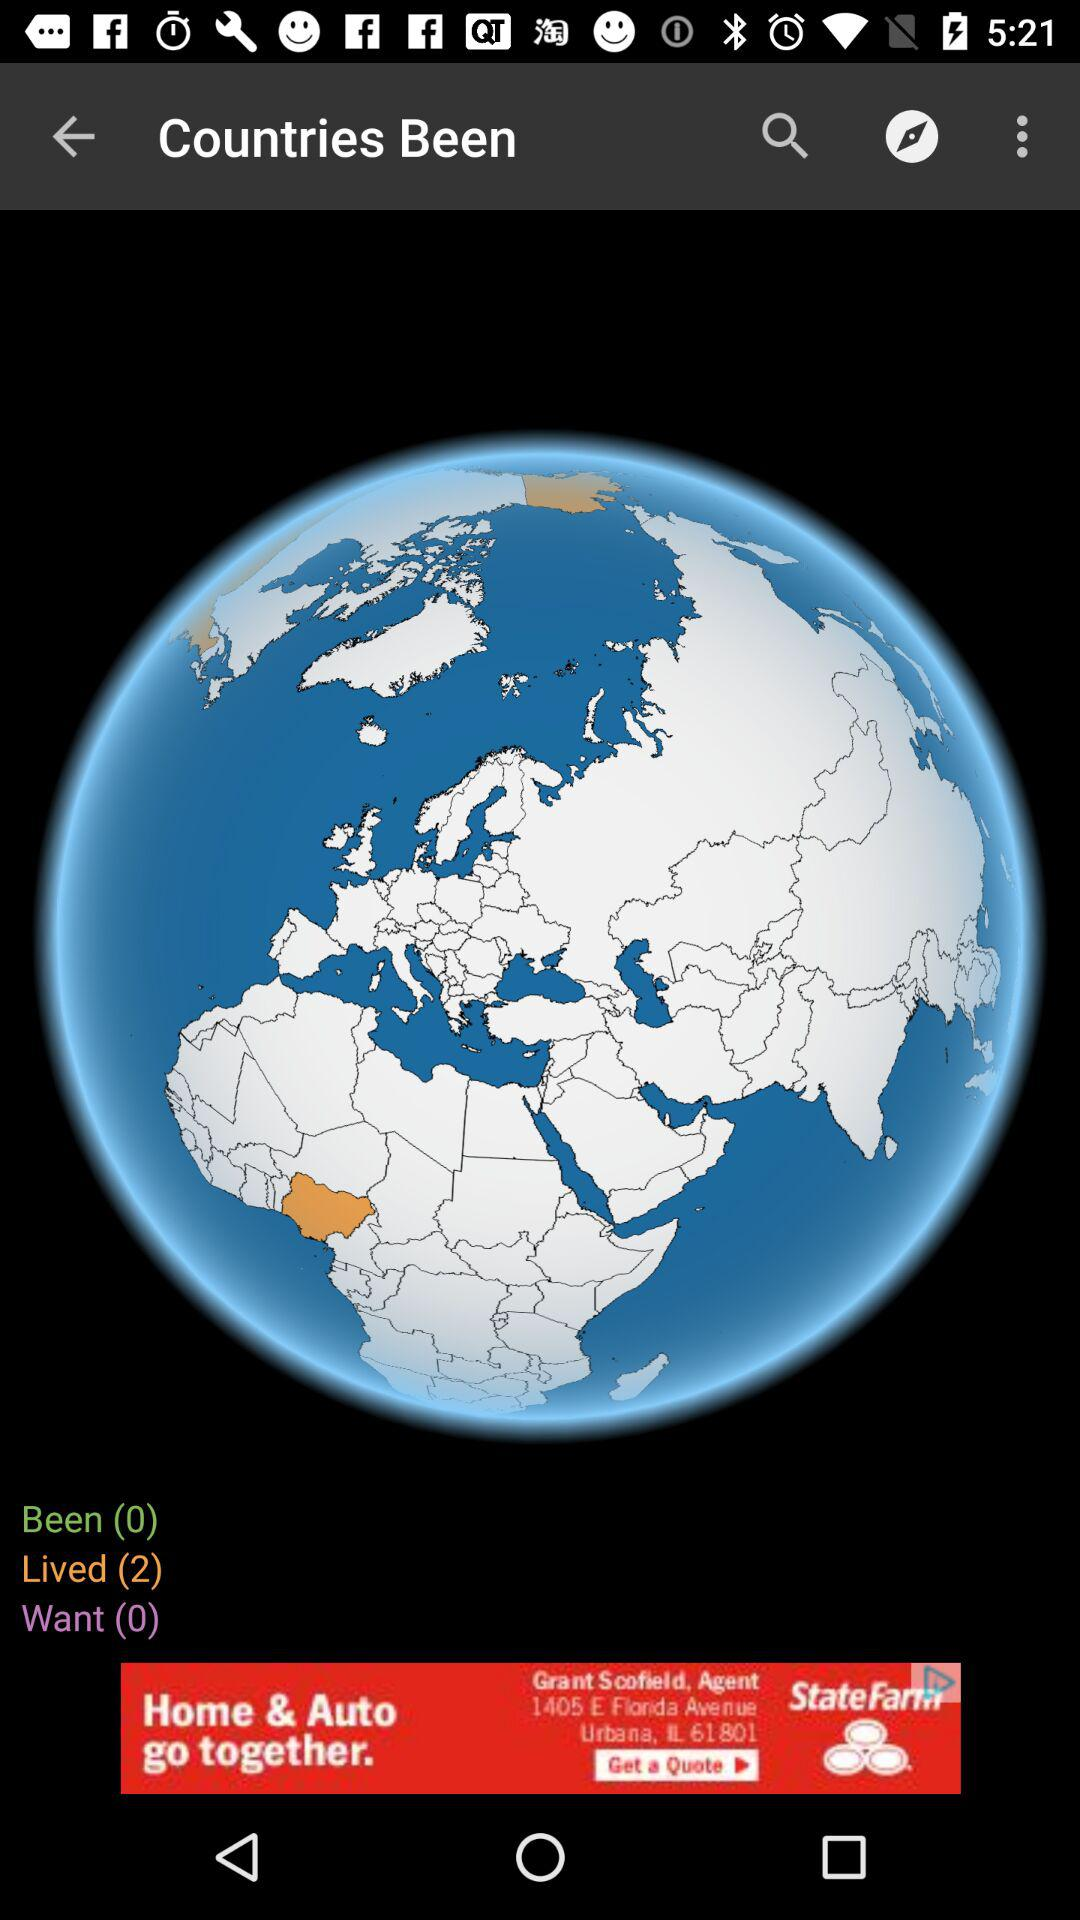What is the number of "Want"? The number is 0. 